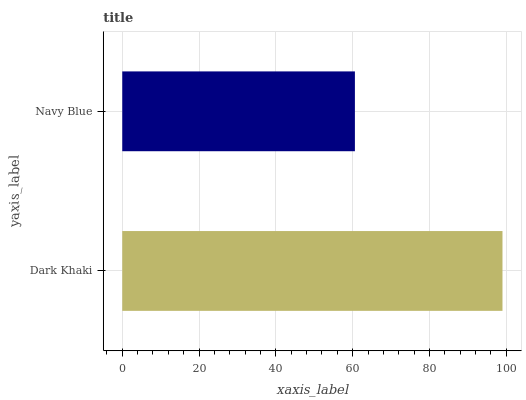Is Navy Blue the minimum?
Answer yes or no. Yes. Is Dark Khaki the maximum?
Answer yes or no. Yes. Is Navy Blue the maximum?
Answer yes or no. No. Is Dark Khaki greater than Navy Blue?
Answer yes or no. Yes. Is Navy Blue less than Dark Khaki?
Answer yes or no. Yes. Is Navy Blue greater than Dark Khaki?
Answer yes or no. No. Is Dark Khaki less than Navy Blue?
Answer yes or no. No. Is Dark Khaki the high median?
Answer yes or no. Yes. Is Navy Blue the low median?
Answer yes or no. Yes. Is Navy Blue the high median?
Answer yes or no. No. Is Dark Khaki the low median?
Answer yes or no. No. 